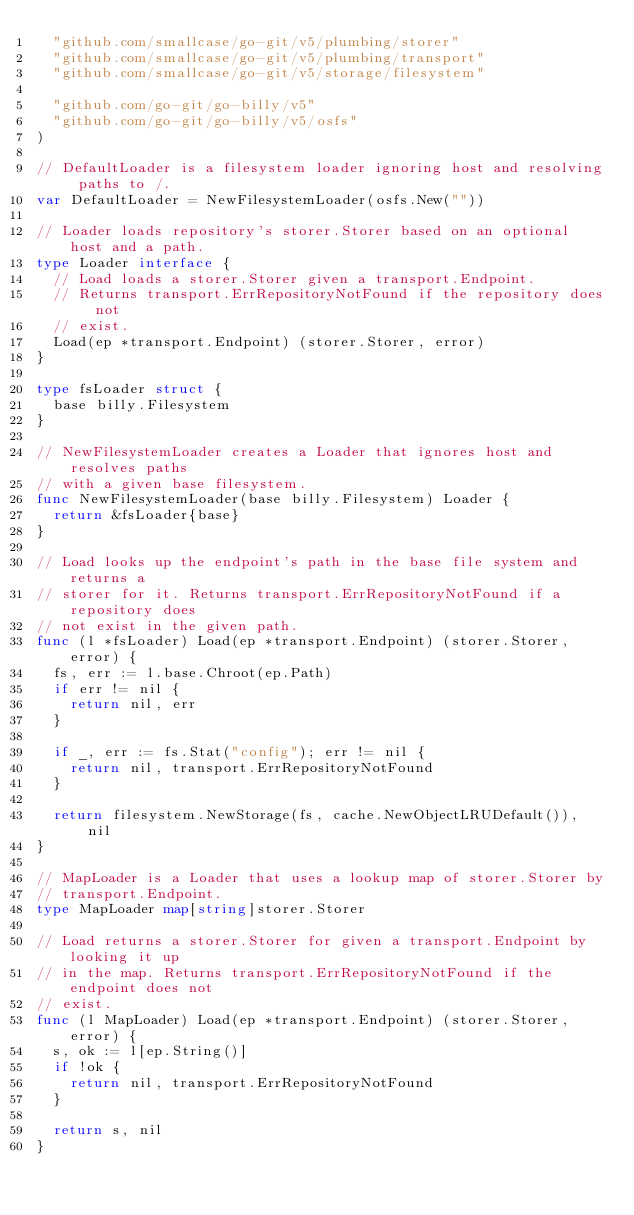Convert code to text. <code><loc_0><loc_0><loc_500><loc_500><_Go_>	"github.com/smallcase/go-git/v5/plumbing/storer"
	"github.com/smallcase/go-git/v5/plumbing/transport"
	"github.com/smallcase/go-git/v5/storage/filesystem"

	"github.com/go-git/go-billy/v5"
	"github.com/go-git/go-billy/v5/osfs"
)

// DefaultLoader is a filesystem loader ignoring host and resolving paths to /.
var DefaultLoader = NewFilesystemLoader(osfs.New(""))

// Loader loads repository's storer.Storer based on an optional host and a path.
type Loader interface {
	// Load loads a storer.Storer given a transport.Endpoint.
	// Returns transport.ErrRepositoryNotFound if the repository does not
	// exist.
	Load(ep *transport.Endpoint) (storer.Storer, error)
}

type fsLoader struct {
	base billy.Filesystem
}

// NewFilesystemLoader creates a Loader that ignores host and resolves paths
// with a given base filesystem.
func NewFilesystemLoader(base billy.Filesystem) Loader {
	return &fsLoader{base}
}

// Load looks up the endpoint's path in the base file system and returns a
// storer for it. Returns transport.ErrRepositoryNotFound if a repository does
// not exist in the given path.
func (l *fsLoader) Load(ep *transport.Endpoint) (storer.Storer, error) {
	fs, err := l.base.Chroot(ep.Path)
	if err != nil {
		return nil, err
	}

	if _, err := fs.Stat("config"); err != nil {
		return nil, transport.ErrRepositoryNotFound
	}

	return filesystem.NewStorage(fs, cache.NewObjectLRUDefault()), nil
}

// MapLoader is a Loader that uses a lookup map of storer.Storer by
// transport.Endpoint.
type MapLoader map[string]storer.Storer

// Load returns a storer.Storer for given a transport.Endpoint by looking it up
// in the map. Returns transport.ErrRepositoryNotFound if the endpoint does not
// exist.
func (l MapLoader) Load(ep *transport.Endpoint) (storer.Storer, error) {
	s, ok := l[ep.String()]
	if !ok {
		return nil, transport.ErrRepositoryNotFound
	}

	return s, nil
}
</code> 